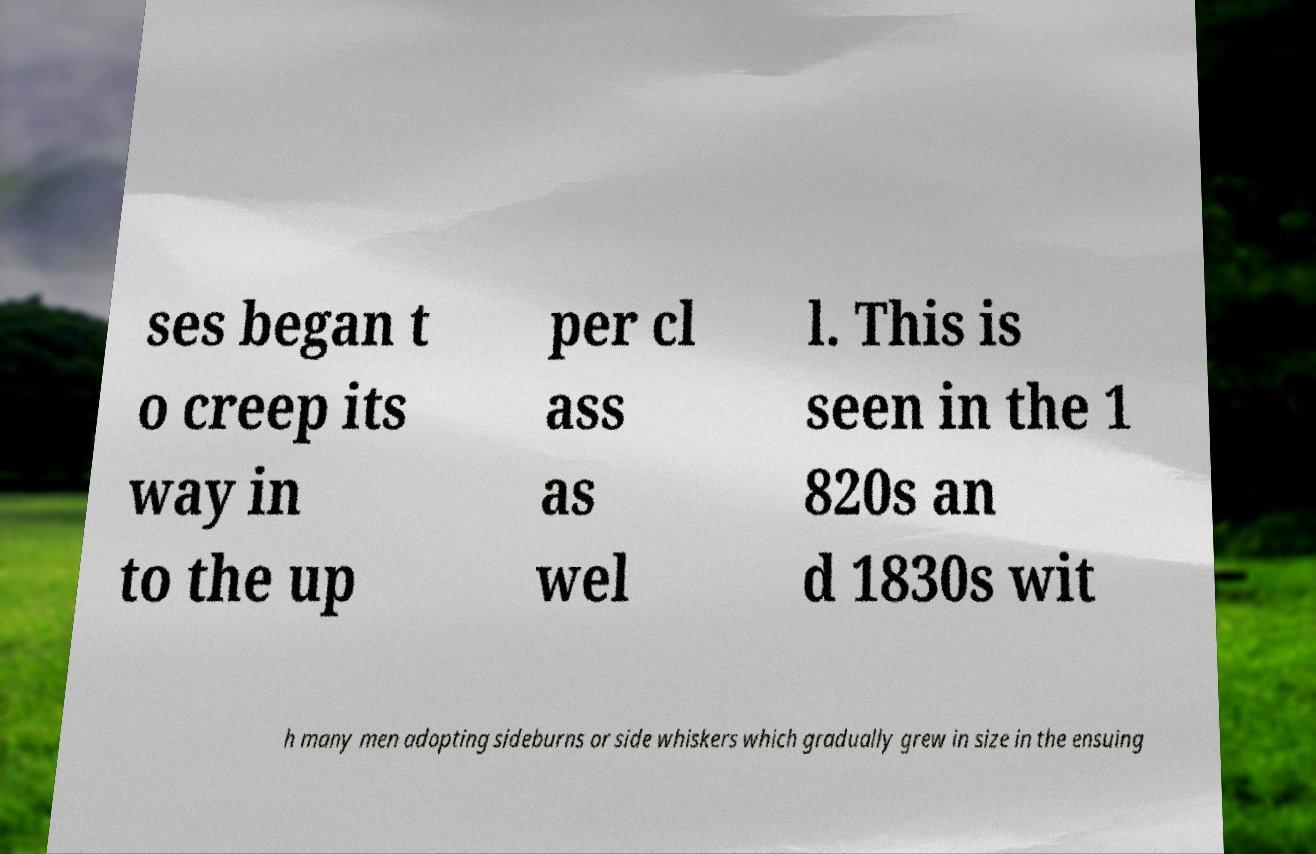Please read and relay the text visible in this image. What does it say? ses began t o creep its way in to the up per cl ass as wel l. This is seen in the 1 820s an d 1830s wit h many men adopting sideburns or side whiskers which gradually grew in size in the ensuing 